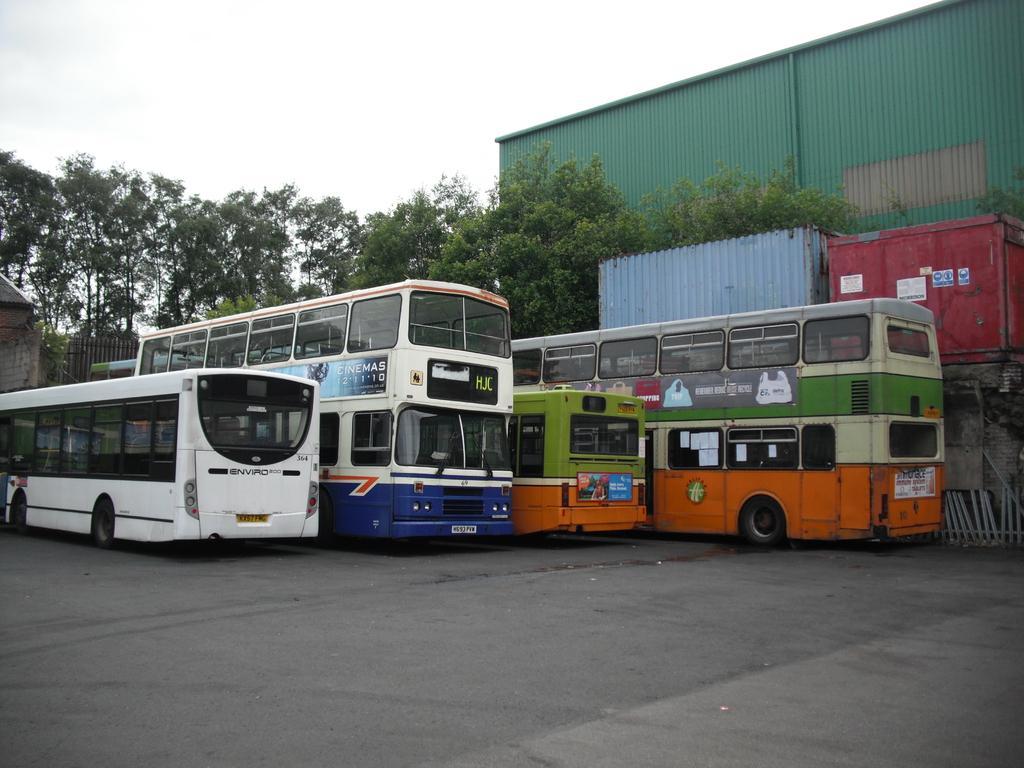Describe this image in one or two sentences. In the image there are two buses and two double decker buses on the floor and behind it there are trees and containers in the back and above its sky. 